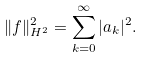Convert formula to latex. <formula><loc_0><loc_0><loc_500><loc_500>\| f \| ^ { 2 } _ { H ^ { 2 } } = \sum _ { k = 0 } ^ { \infty } | a _ { k } | ^ { 2 } .</formula> 